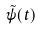<formula> <loc_0><loc_0><loc_500><loc_500>\tilde { \psi } ( t )</formula> 